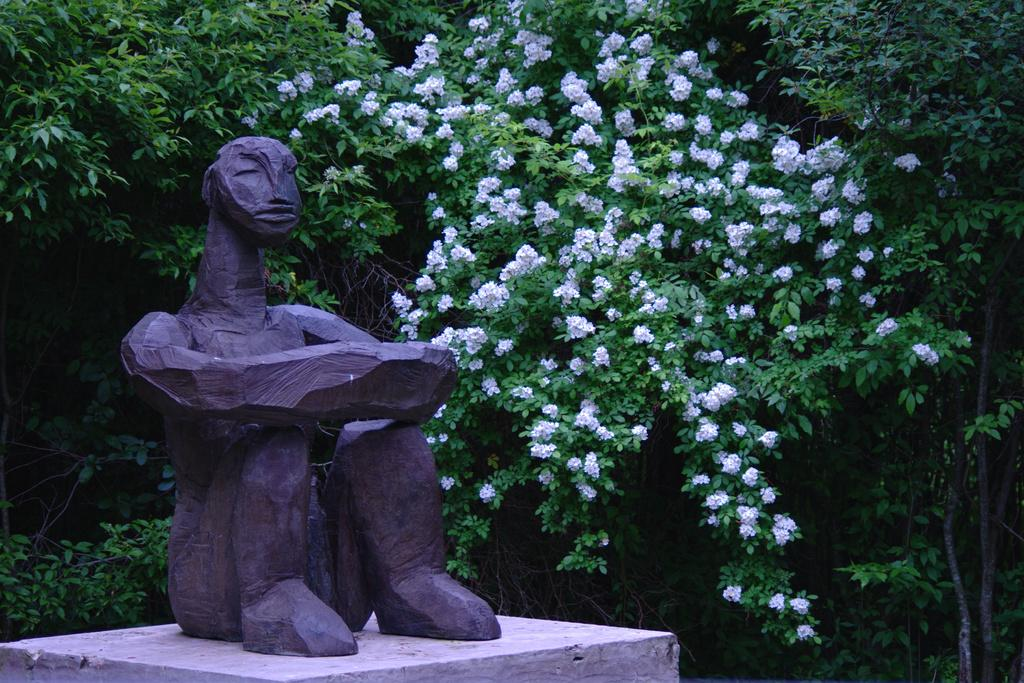What is the main subject in the image? There is a statue in the image. What can be seen behind the statue? There are flowers and trees behind the statue. What type of cherries can be seen growing on the statue in the image? There are no cherries present in the image, and the statue does not have any growing on it. 